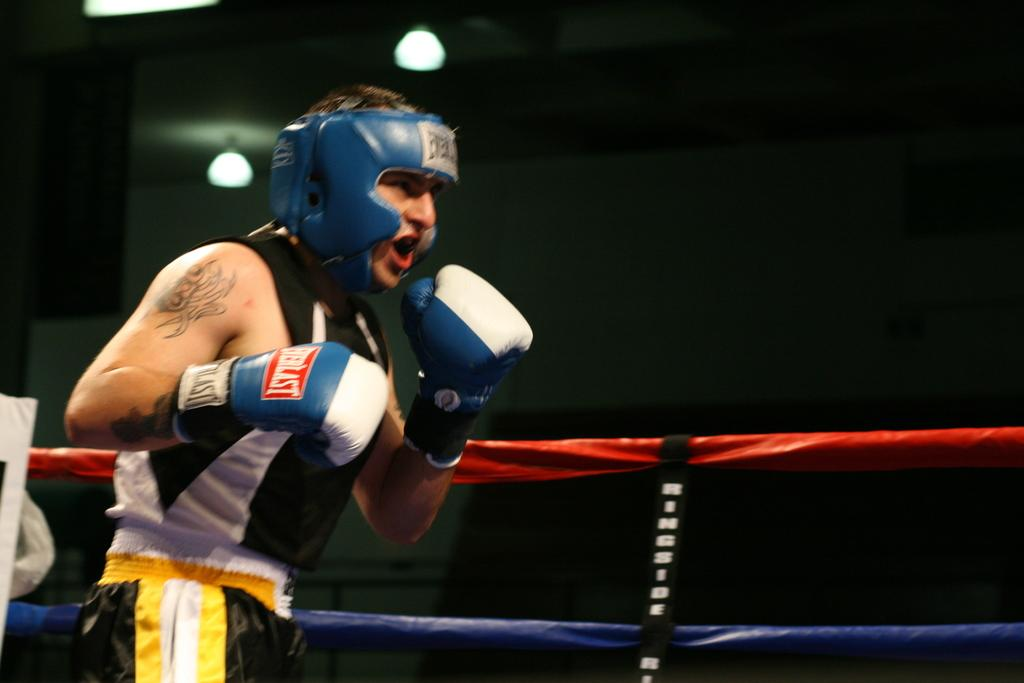What is the person in the image wearing on their head? The person is wearing a blue helmet. What color is the dress the person is wearing? The person is wearing a black dress. What type of protective gear is the person wearing on their hands? The person is wearing gloves. Where is the person standing in the image? The person is standing on a stage. What can be seen in the background of the image? There is fencing and lights in the background of the image. What type of cheese is being served at the competition in the image? There is no cheese or competition present in the image; it features a person standing on a stage wearing a black dress, blue helmet, and gloves. 